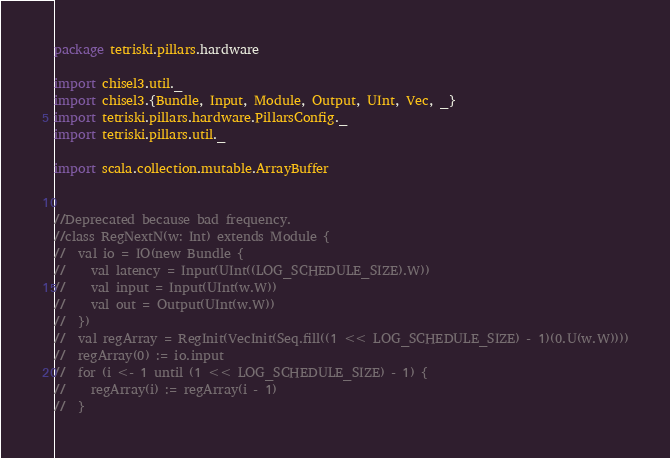<code> <loc_0><loc_0><loc_500><loc_500><_Scala_>package tetriski.pillars.hardware

import chisel3.util._
import chisel3.{Bundle, Input, Module, Output, UInt, Vec, _}
import tetriski.pillars.hardware.PillarsConfig._
import tetriski.pillars.util._

import scala.collection.mutable.ArrayBuffer


//Deprecated because bad frequency.
//class RegNextN(w: Int) extends Module {
//  val io = IO(new Bundle {
//    val latency = Input(UInt((LOG_SCHEDULE_SIZE).W))
//    val input = Input(UInt(w.W))
//    val out = Output(UInt(w.W))
//  })
//  val regArray = RegInit(VecInit(Seq.fill((1 << LOG_SCHEDULE_SIZE) - 1)(0.U(w.W))))
//  regArray(0) := io.input
//  for (i <- 1 until (1 << LOG_SCHEDULE_SIZE) - 1) {
//    regArray(i) := regArray(i - 1)
//  }</code> 